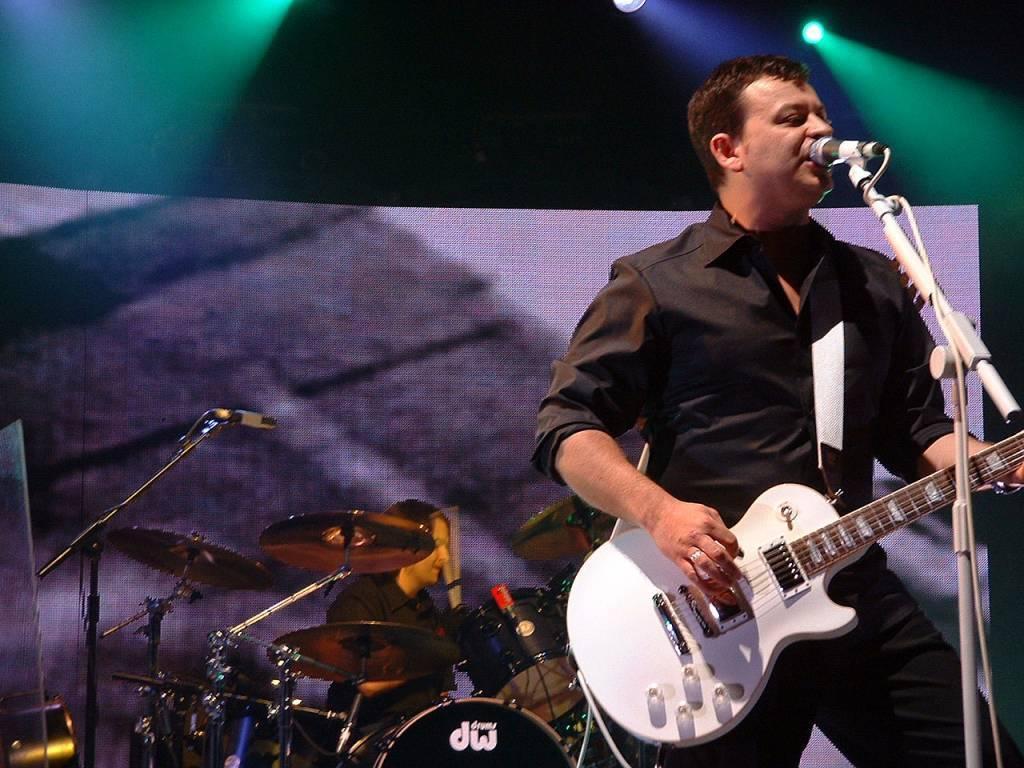Please provide a concise description of this image. In this image I can see a man is standing and holding a guitar. In the background I can see another man is sitting next to a drum set. I can also see few mics. 